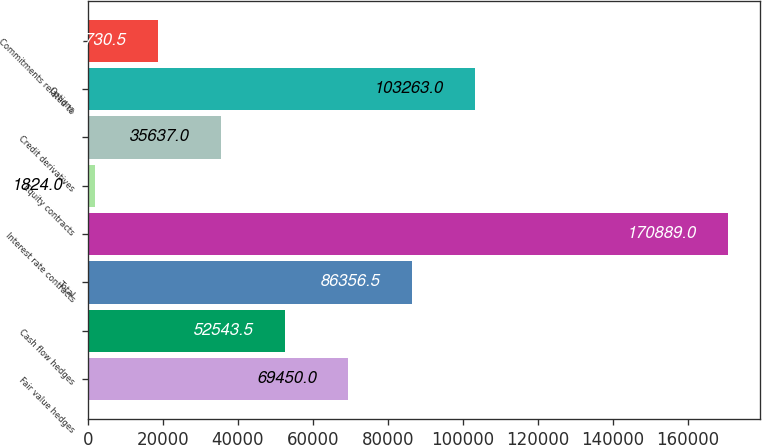Convert chart. <chart><loc_0><loc_0><loc_500><loc_500><bar_chart><fcel>Fair value hedges<fcel>Cash flow hedges<fcel>Total<fcel>Interest rate contracts<fcel>Equity contracts<fcel>Credit derivatives<fcel>Options<fcel>Commitments related to<nl><fcel>69450<fcel>52543.5<fcel>86356.5<fcel>170889<fcel>1824<fcel>35637<fcel>103263<fcel>18730.5<nl></chart> 